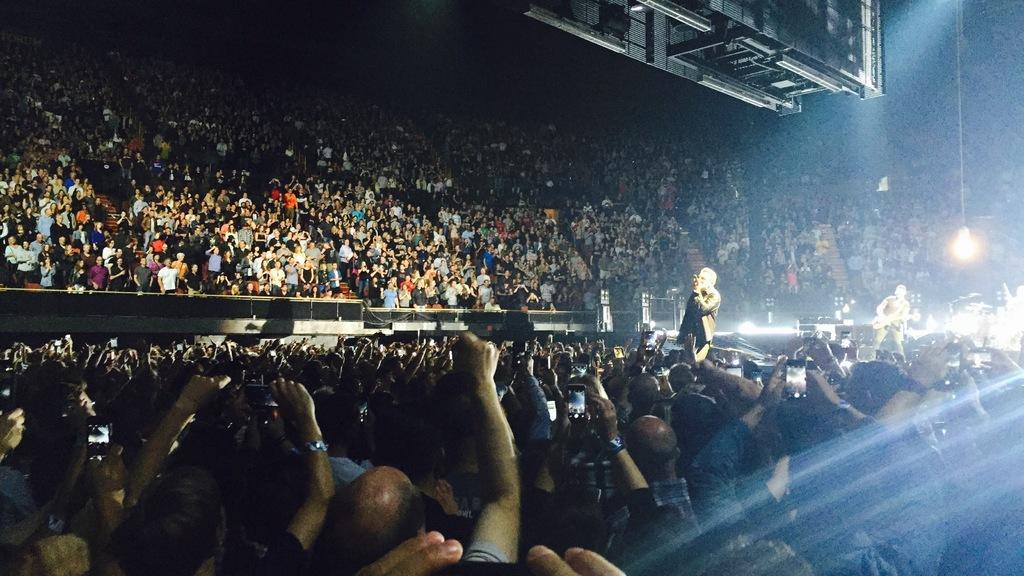Describe this image in one or two sentences. In this picture we can see group of people are standing, some of them are holding mobile phone, a person on the right side is holding a guitar, in the background there are some lights. 